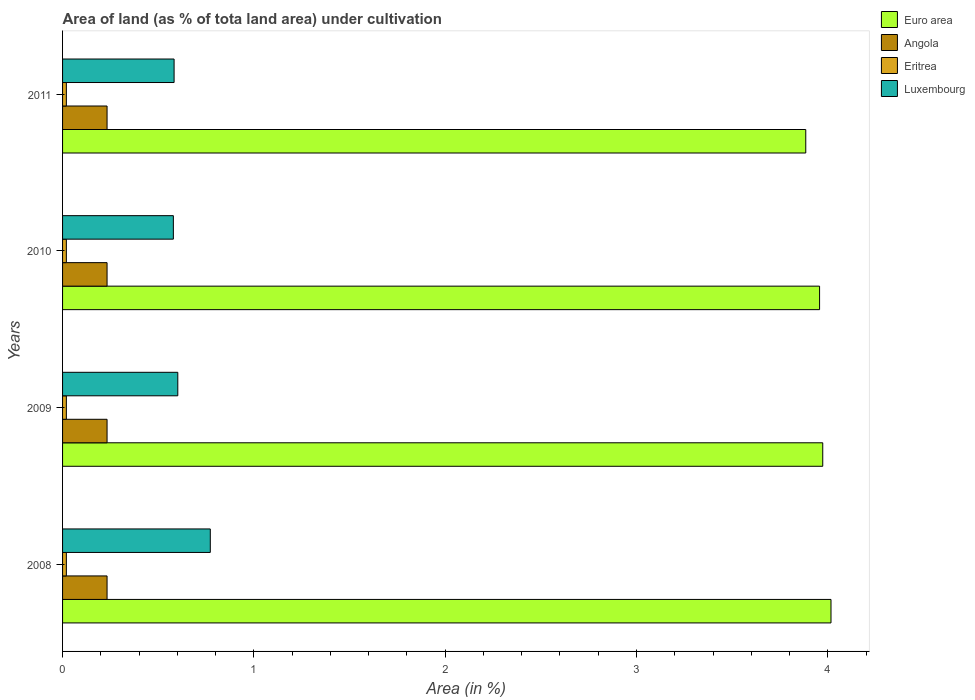How many groups of bars are there?
Ensure brevity in your answer.  4. Are the number of bars per tick equal to the number of legend labels?
Ensure brevity in your answer.  Yes. Are the number of bars on each tick of the Y-axis equal?
Offer a very short reply. Yes. How many bars are there on the 3rd tick from the top?
Keep it short and to the point. 4. What is the label of the 2nd group of bars from the top?
Ensure brevity in your answer.  2010. What is the percentage of land under cultivation in Eritrea in 2010?
Your answer should be very brief. 0.02. Across all years, what is the maximum percentage of land under cultivation in Eritrea?
Give a very brief answer. 0.02. Across all years, what is the minimum percentage of land under cultivation in Eritrea?
Keep it short and to the point. 0.02. In which year was the percentage of land under cultivation in Angola maximum?
Make the answer very short. 2008. What is the total percentage of land under cultivation in Euro area in the graph?
Offer a terse response. 15.83. What is the difference between the percentage of land under cultivation in Euro area in 2009 and the percentage of land under cultivation in Eritrea in 2008?
Your response must be concise. 3.95. What is the average percentage of land under cultivation in Angola per year?
Your answer should be compact. 0.23. In the year 2010, what is the difference between the percentage of land under cultivation in Angola and percentage of land under cultivation in Eritrea?
Make the answer very short. 0.21. What is the ratio of the percentage of land under cultivation in Luxembourg in 2009 to that in 2010?
Provide a succinct answer. 1.04. What is the difference between the highest and the lowest percentage of land under cultivation in Eritrea?
Your answer should be very brief. 0. In how many years, is the percentage of land under cultivation in Eritrea greater than the average percentage of land under cultivation in Eritrea taken over all years?
Provide a succinct answer. 0. What does the 1st bar from the top in 2010 represents?
Provide a short and direct response. Luxembourg. What does the 1st bar from the bottom in 2011 represents?
Your response must be concise. Euro area. How many years are there in the graph?
Ensure brevity in your answer.  4. What is the difference between two consecutive major ticks on the X-axis?
Give a very brief answer. 1. Does the graph contain any zero values?
Offer a terse response. No. How many legend labels are there?
Your answer should be compact. 4. How are the legend labels stacked?
Your answer should be very brief. Vertical. What is the title of the graph?
Your answer should be very brief. Area of land (as % of tota land area) under cultivation. What is the label or title of the X-axis?
Ensure brevity in your answer.  Area (in %). What is the label or title of the Y-axis?
Provide a succinct answer. Years. What is the Area (in %) in Euro area in 2008?
Provide a succinct answer. 4.02. What is the Area (in %) of Angola in 2008?
Your answer should be compact. 0.23. What is the Area (in %) of Eritrea in 2008?
Give a very brief answer. 0.02. What is the Area (in %) in Luxembourg in 2008?
Provide a short and direct response. 0.77. What is the Area (in %) of Euro area in 2009?
Offer a very short reply. 3.97. What is the Area (in %) in Angola in 2009?
Offer a terse response. 0.23. What is the Area (in %) in Eritrea in 2009?
Your response must be concise. 0.02. What is the Area (in %) of Luxembourg in 2009?
Your answer should be very brief. 0.6. What is the Area (in %) of Euro area in 2010?
Your answer should be compact. 3.96. What is the Area (in %) in Angola in 2010?
Your answer should be very brief. 0.23. What is the Area (in %) of Eritrea in 2010?
Keep it short and to the point. 0.02. What is the Area (in %) of Luxembourg in 2010?
Give a very brief answer. 0.58. What is the Area (in %) in Euro area in 2011?
Give a very brief answer. 3.88. What is the Area (in %) in Angola in 2011?
Provide a short and direct response. 0.23. What is the Area (in %) of Eritrea in 2011?
Ensure brevity in your answer.  0.02. What is the Area (in %) in Luxembourg in 2011?
Offer a very short reply. 0.58. Across all years, what is the maximum Area (in %) of Euro area?
Provide a short and direct response. 4.02. Across all years, what is the maximum Area (in %) of Angola?
Keep it short and to the point. 0.23. Across all years, what is the maximum Area (in %) in Eritrea?
Offer a very short reply. 0.02. Across all years, what is the maximum Area (in %) of Luxembourg?
Your answer should be very brief. 0.77. Across all years, what is the minimum Area (in %) in Euro area?
Provide a succinct answer. 3.88. Across all years, what is the minimum Area (in %) in Angola?
Offer a terse response. 0.23. Across all years, what is the minimum Area (in %) of Eritrea?
Ensure brevity in your answer.  0.02. Across all years, what is the minimum Area (in %) in Luxembourg?
Ensure brevity in your answer.  0.58. What is the total Area (in %) of Euro area in the graph?
Provide a succinct answer. 15.83. What is the total Area (in %) of Angola in the graph?
Offer a very short reply. 0.93. What is the total Area (in %) of Eritrea in the graph?
Offer a very short reply. 0.08. What is the total Area (in %) in Luxembourg in the graph?
Offer a terse response. 2.54. What is the difference between the Area (in %) of Euro area in 2008 and that in 2009?
Your response must be concise. 0.04. What is the difference between the Area (in %) in Luxembourg in 2008 and that in 2009?
Ensure brevity in your answer.  0.17. What is the difference between the Area (in %) in Euro area in 2008 and that in 2010?
Offer a terse response. 0.06. What is the difference between the Area (in %) in Angola in 2008 and that in 2010?
Keep it short and to the point. 0. What is the difference between the Area (in %) in Eritrea in 2008 and that in 2010?
Your answer should be very brief. 0. What is the difference between the Area (in %) in Luxembourg in 2008 and that in 2010?
Offer a very short reply. 0.19. What is the difference between the Area (in %) of Euro area in 2008 and that in 2011?
Provide a succinct answer. 0.13. What is the difference between the Area (in %) of Eritrea in 2008 and that in 2011?
Your answer should be very brief. 0. What is the difference between the Area (in %) in Luxembourg in 2008 and that in 2011?
Offer a terse response. 0.19. What is the difference between the Area (in %) of Euro area in 2009 and that in 2010?
Keep it short and to the point. 0.02. What is the difference between the Area (in %) in Angola in 2009 and that in 2010?
Make the answer very short. 0. What is the difference between the Area (in %) of Eritrea in 2009 and that in 2010?
Offer a very short reply. 0. What is the difference between the Area (in %) in Luxembourg in 2009 and that in 2010?
Make the answer very short. 0.02. What is the difference between the Area (in %) of Euro area in 2009 and that in 2011?
Ensure brevity in your answer.  0.09. What is the difference between the Area (in %) of Angola in 2009 and that in 2011?
Your response must be concise. 0. What is the difference between the Area (in %) in Eritrea in 2009 and that in 2011?
Your answer should be very brief. 0. What is the difference between the Area (in %) in Luxembourg in 2009 and that in 2011?
Offer a terse response. 0.02. What is the difference between the Area (in %) in Euro area in 2010 and that in 2011?
Ensure brevity in your answer.  0.07. What is the difference between the Area (in %) in Angola in 2010 and that in 2011?
Your response must be concise. 0. What is the difference between the Area (in %) of Eritrea in 2010 and that in 2011?
Keep it short and to the point. 0. What is the difference between the Area (in %) of Luxembourg in 2010 and that in 2011?
Your response must be concise. -0. What is the difference between the Area (in %) in Euro area in 2008 and the Area (in %) in Angola in 2009?
Provide a short and direct response. 3.78. What is the difference between the Area (in %) in Euro area in 2008 and the Area (in %) in Eritrea in 2009?
Your answer should be very brief. 4. What is the difference between the Area (in %) of Euro area in 2008 and the Area (in %) of Luxembourg in 2009?
Provide a succinct answer. 3.41. What is the difference between the Area (in %) in Angola in 2008 and the Area (in %) in Eritrea in 2009?
Your answer should be compact. 0.21. What is the difference between the Area (in %) of Angola in 2008 and the Area (in %) of Luxembourg in 2009?
Offer a very short reply. -0.37. What is the difference between the Area (in %) in Eritrea in 2008 and the Area (in %) in Luxembourg in 2009?
Keep it short and to the point. -0.58. What is the difference between the Area (in %) of Euro area in 2008 and the Area (in %) of Angola in 2010?
Keep it short and to the point. 3.78. What is the difference between the Area (in %) of Euro area in 2008 and the Area (in %) of Eritrea in 2010?
Offer a very short reply. 4. What is the difference between the Area (in %) of Euro area in 2008 and the Area (in %) of Luxembourg in 2010?
Make the answer very short. 3.44. What is the difference between the Area (in %) in Angola in 2008 and the Area (in %) in Eritrea in 2010?
Make the answer very short. 0.21. What is the difference between the Area (in %) of Angola in 2008 and the Area (in %) of Luxembourg in 2010?
Your answer should be compact. -0.35. What is the difference between the Area (in %) of Eritrea in 2008 and the Area (in %) of Luxembourg in 2010?
Ensure brevity in your answer.  -0.56. What is the difference between the Area (in %) of Euro area in 2008 and the Area (in %) of Angola in 2011?
Offer a very short reply. 3.78. What is the difference between the Area (in %) in Euro area in 2008 and the Area (in %) in Eritrea in 2011?
Keep it short and to the point. 4. What is the difference between the Area (in %) of Euro area in 2008 and the Area (in %) of Luxembourg in 2011?
Offer a very short reply. 3.43. What is the difference between the Area (in %) in Angola in 2008 and the Area (in %) in Eritrea in 2011?
Your response must be concise. 0.21. What is the difference between the Area (in %) in Angola in 2008 and the Area (in %) in Luxembourg in 2011?
Offer a terse response. -0.35. What is the difference between the Area (in %) of Eritrea in 2008 and the Area (in %) of Luxembourg in 2011?
Offer a very short reply. -0.56. What is the difference between the Area (in %) in Euro area in 2009 and the Area (in %) in Angola in 2010?
Keep it short and to the point. 3.74. What is the difference between the Area (in %) of Euro area in 2009 and the Area (in %) of Eritrea in 2010?
Your answer should be compact. 3.95. What is the difference between the Area (in %) of Euro area in 2009 and the Area (in %) of Luxembourg in 2010?
Your response must be concise. 3.39. What is the difference between the Area (in %) in Angola in 2009 and the Area (in %) in Eritrea in 2010?
Give a very brief answer. 0.21. What is the difference between the Area (in %) of Angola in 2009 and the Area (in %) of Luxembourg in 2010?
Make the answer very short. -0.35. What is the difference between the Area (in %) of Eritrea in 2009 and the Area (in %) of Luxembourg in 2010?
Keep it short and to the point. -0.56. What is the difference between the Area (in %) of Euro area in 2009 and the Area (in %) of Angola in 2011?
Give a very brief answer. 3.74. What is the difference between the Area (in %) of Euro area in 2009 and the Area (in %) of Eritrea in 2011?
Offer a very short reply. 3.95. What is the difference between the Area (in %) of Euro area in 2009 and the Area (in %) of Luxembourg in 2011?
Make the answer very short. 3.39. What is the difference between the Area (in %) of Angola in 2009 and the Area (in %) of Eritrea in 2011?
Your answer should be very brief. 0.21. What is the difference between the Area (in %) of Angola in 2009 and the Area (in %) of Luxembourg in 2011?
Offer a terse response. -0.35. What is the difference between the Area (in %) in Eritrea in 2009 and the Area (in %) in Luxembourg in 2011?
Provide a succinct answer. -0.56. What is the difference between the Area (in %) of Euro area in 2010 and the Area (in %) of Angola in 2011?
Offer a very short reply. 3.72. What is the difference between the Area (in %) of Euro area in 2010 and the Area (in %) of Eritrea in 2011?
Offer a very short reply. 3.94. What is the difference between the Area (in %) of Euro area in 2010 and the Area (in %) of Luxembourg in 2011?
Your answer should be very brief. 3.37. What is the difference between the Area (in %) in Angola in 2010 and the Area (in %) in Eritrea in 2011?
Provide a succinct answer. 0.21. What is the difference between the Area (in %) in Angola in 2010 and the Area (in %) in Luxembourg in 2011?
Offer a terse response. -0.35. What is the difference between the Area (in %) of Eritrea in 2010 and the Area (in %) of Luxembourg in 2011?
Offer a very short reply. -0.56. What is the average Area (in %) in Euro area per year?
Keep it short and to the point. 3.96. What is the average Area (in %) of Angola per year?
Ensure brevity in your answer.  0.23. What is the average Area (in %) in Eritrea per year?
Provide a succinct answer. 0.02. What is the average Area (in %) of Luxembourg per year?
Offer a very short reply. 0.63. In the year 2008, what is the difference between the Area (in %) of Euro area and Area (in %) of Angola?
Your response must be concise. 3.78. In the year 2008, what is the difference between the Area (in %) of Euro area and Area (in %) of Eritrea?
Your response must be concise. 4. In the year 2008, what is the difference between the Area (in %) of Euro area and Area (in %) of Luxembourg?
Keep it short and to the point. 3.24. In the year 2008, what is the difference between the Area (in %) of Angola and Area (in %) of Eritrea?
Give a very brief answer. 0.21. In the year 2008, what is the difference between the Area (in %) in Angola and Area (in %) in Luxembourg?
Your response must be concise. -0.54. In the year 2008, what is the difference between the Area (in %) in Eritrea and Area (in %) in Luxembourg?
Provide a succinct answer. -0.75. In the year 2009, what is the difference between the Area (in %) of Euro area and Area (in %) of Angola?
Keep it short and to the point. 3.74. In the year 2009, what is the difference between the Area (in %) in Euro area and Area (in %) in Eritrea?
Give a very brief answer. 3.95. In the year 2009, what is the difference between the Area (in %) of Euro area and Area (in %) of Luxembourg?
Provide a short and direct response. 3.37. In the year 2009, what is the difference between the Area (in %) of Angola and Area (in %) of Eritrea?
Make the answer very short. 0.21. In the year 2009, what is the difference between the Area (in %) of Angola and Area (in %) of Luxembourg?
Keep it short and to the point. -0.37. In the year 2009, what is the difference between the Area (in %) of Eritrea and Area (in %) of Luxembourg?
Your answer should be very brief. -0.58. In the year 2010, what is the difference between the Area (in %) in Euro area and Area (in %) in Angola?
Offer a terse response. 3.72. In the year 2010, what is the difference between the Area (in %) in Euro area and Area (in %) in Eritrea?
Keep it short and to the point. 3.94. In the year 2010, what is the difference between the Area (in %) of Euro area and Area (in %) of Luxembourg?
Keep it short and to the point. 3.38. In the year 2010, what is the difference between the Area (in %) in Angola and Area (in %) in Eritrea?
Make the answer very short. 0.21. In the year 2010, what is the difference between the Area (in %) of Angola and Area (in %) of Luxembourg?
Your answer should be compact. -0.35. In the year 2010, what is the difference between the Area (in %) of Eritrea and Area (in %) of Luxembourg?
Your answer should be compact. -0.56. In the year 2011, what is the difference between the Area (in %) in Euro area and Area (in %) in Angola?
Your answer should be compact. 3.65. In the year 2011, what is the difference between the Area (in %) in Euro area and Area (in %) in Eritrea?
Your response must be concise. 3.87. In the year 2011, what is the difference between the Area (in %) of Euro area and Area (in %) of Luxembourg?
Give a very brief answer. 3.3. In the year 2011, what is the difference between the Area (in %) in Angola and Area (in %) in Eritrea?
Provide a succinct answer. 0.21. In the year 2011, what is the difference between the Area (in %) in Angola and Area (in %) in Luxembourg?
Offer a very short reply. -0.35. In the year 2011, what is the difference between the Area (in %) in Eritrea and Area (in %) in Luxembourg?
Provide a succinct answer. -0.56. What is the ratio of the Area (in %) in Euro area in 2008 to that in 2009?
Your answer should be very brief. 1.01. What is the ratio of the Area (in %) in Luxembourg in 2008 to that in 2009?
Your response must be concise. 1.28. What is the ratio of the Area (in %) of Euro area in 2008 to that in 2010?
Give a very brief answer. 1.02. What is the ratio of the Area (in %) in Luxembourg in 2008 to that in 2010?
Your answer should be compact. 1.33. What is the ratio of the Area (in %) of Euro area in 2008 to that in 2011?
Offer a terse response. 1.03. What is the ratio of the Area (in %) of Luxembourg in 2008 to that in 2011?
Make the answer very short. 1.32. What is the ratio of the Area (in %) in Euro area in 2009 to that in 2010?
Make the answer very short. 1. What is the ratio of the Area (in %) in Euro area in 2009 to that in 2011?
Give a very brief answer. 1.02. What is the ratio of the Area (in %) in Angola in 2009 to that in 2011?
Your answer should be very brief. 1. What is the ratio of the Area (in %) in Eritrea in 2009 to that in 2011?
Offer a very short reply. 1. What is the ratio of the Area (in %) in Luxembourg in 2009 to that in 2011?
Offer a very short reply. 1.03. What is the ratio of the Area (in %) in Euro area in 2010 to that in 2011?
Provide a succinct answer. 1.02. What is the ratio of the Area (in %) in Angola in 2010 to that in 2011?
Keep it short and to the point. 1. What is the difference between the highest and the second highest Area (in %) in Euro area?
Make the answer very short. 0.04. What is the difference between the highest and the second highest Area (in %) in Angola?
Provide a succinct answer. 0. What is the difference between the highest and the second highest Area (in %) in Eritrea?
Your response must be concise. 0. What is the difference between the highest and the second highest Area (in %) of Luxembourg?
Give a very brief answer. 0.17. What is the difference between the highest and the lowest Area (in %) of Euro area?
Your answer should be very brief. 0.13. What is the difference between the highest and the lowest Area (in %) in Luxembourg?
Provide a succinct answer. 0.19. 